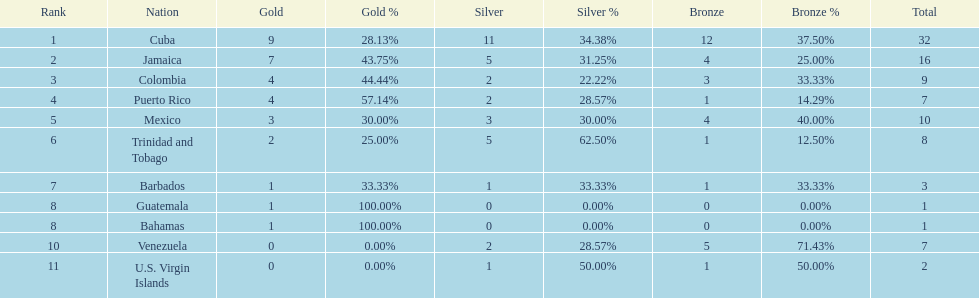Which team had four gold models and one bronze medal? Puerto Rico. 